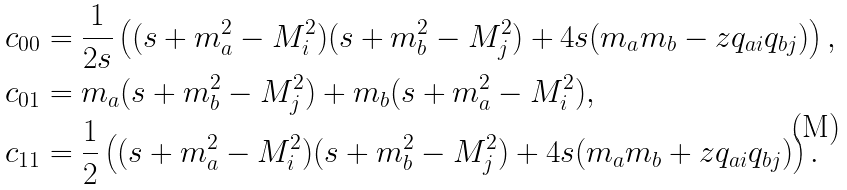<formula> <loc_0><loc_0><loc_500><loc_500>c _ { 0 0 } & = \frac { 1 } { 2 s } \left ( ( s + m _ { a } ^ { 2 } - M _ { i } ^ { 2 } ) ( s + m _ { b } ^ { 2 } - M _ { j } ^ { 2 } ) + 4 s ( m _ { a } m _ { b } - z q _ { a i } q _ { b j } ) \right ) , \\ c _ { 0 1 } & = m _ { a } ( s + m _ { b } ^ { 2 } - M _ { j } ^ { 2 } ) + m _ { b } ( s + m _ { a } ^ { 2 } - M _ { i } ^ { 2 } ) , \\ c _ { 1 1 } & = \frac { 1 } { 2 } \left ( ( s + m _ { a } ^ { 2 } - M _ { i } ^ { 2 } ) ( s + m _ { b } ^ { 2 } - M _ { j } ^ { 2 } ) + 4 s ( m _ { a } m _ { b } + z q _ { a i } q _ { b j } ) \right ) .</formula> 